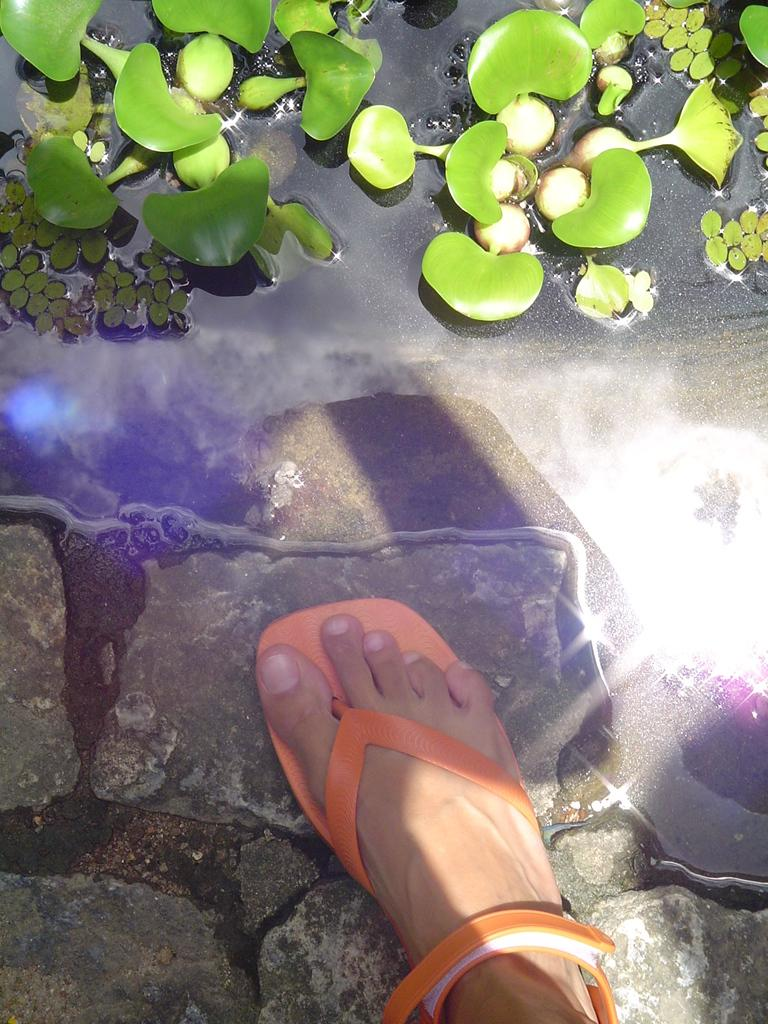What can be seen in the bottom right side of the image? There is a leg and footwear in the bottom right side of the image. What is visible in the top of the image? There is water visible in the top of the image. What type of vegetation is present in the water? There are plants in the water. Can you tell me how many bones are visible in the image? There are no bones present in the image. What type of desk can be seen in the image? There is no desk present in the image. 